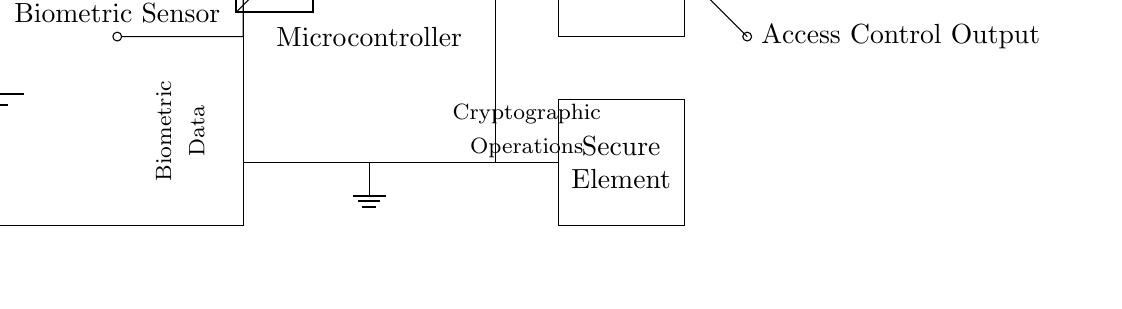What component is labeled as "Biometric Sensor"? The "Biometric Sensor" is directly labeled in the circuit diagram, indicating it is a designated component for verifying identity through biometric data.
Answer: Biometric Sensor What is the function of the Microcontroller in this circuit? The Microcontroller typically processes data from the Biometric Sensor, performs computations, and manages communication with other components, though it is not explicitly stated in the diagram.
Answer: Data processing What type of element is the "Secure Element"? The "Secure Element" is a vital part for encrypted storage and cryptographic operations, indicating it provides a secure environment for sensitive operations.
Answer: Cryptographic element What do the arrows connected to the output indicate? The arrows show the flow of information towards the "Access Control Output", which suggests it signals whether access is granted or denied based on processed biometric data.
Answer: Access signal How does biometric data flow within this circuit? The biometric data flows from the Biometric Sensor to the Microcontroller, which sends it to the ADC, processes it, and ultimately controls access through the output.
Answer: From sensor to controller to output What is the power supply voltage indicated as "Vcc"? The diagram mentions "Vcc" beside the battery component, which typically represents the main supply voltage for the circuit.
Answer: Vcc What is connected to the Memory component? The Memory component is connected to the Microcontroller, which indicates it likely stores processed biometric information for verification and comparison.
Answer: Microcontroller 